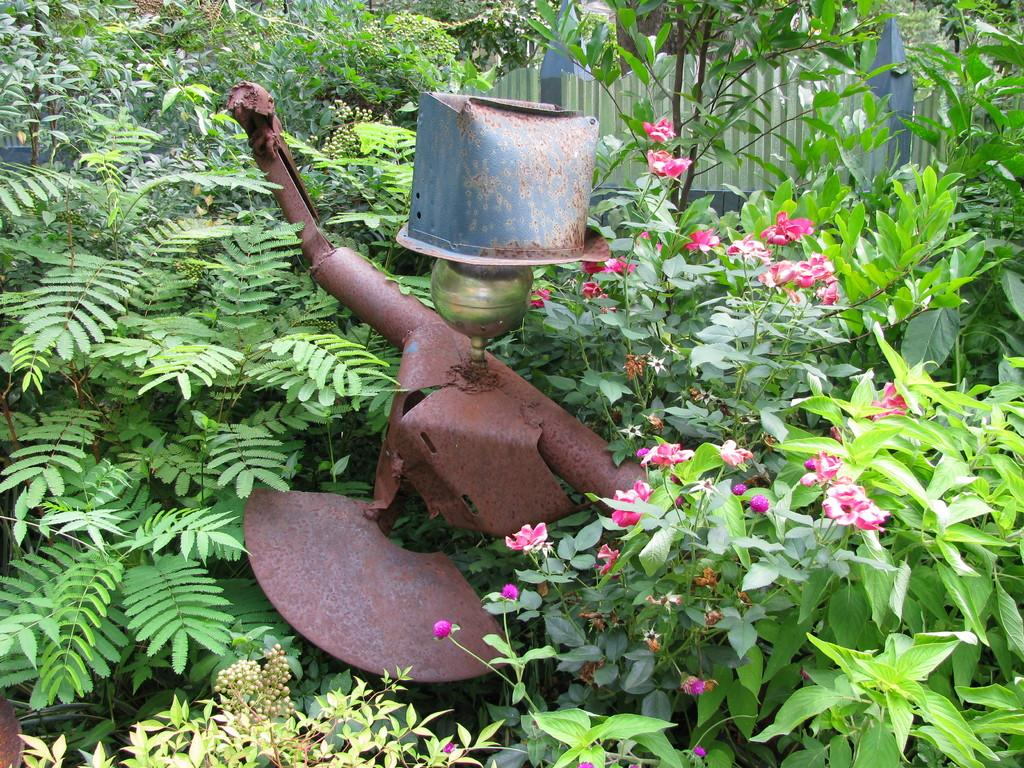What type of objects are located in the center of the image? There are metal objects in the center of the image. What kind of living organisms can be seen in the image? There are plants and flowers in the image. Can you describe the objects in the background of the image? Unfortunately, the provided facts do not give any information about the objects in the background. What type of holiday is being celebrated in the image? There is no indication of a holiday being celebrated in the image. What activity are the plants and flowers participating in? The plants and flowers are not participating in any activity, as they are inanimate objects. 